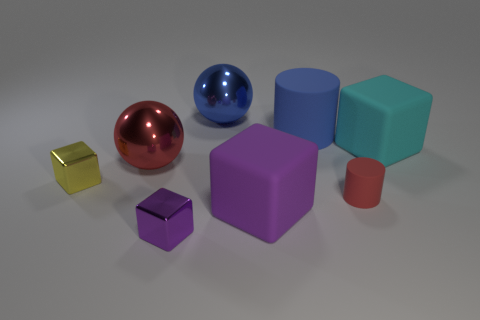Can you describe the size comparison between the objects? Certainly! The largest object is the purple rubber block, while the smallest appears to be the metallic cube beside the yellow one. The spheres are of similar size but smaller than the blue and cyan blocks, whereas the red cylinder is the least wide object but has a moderate height. 